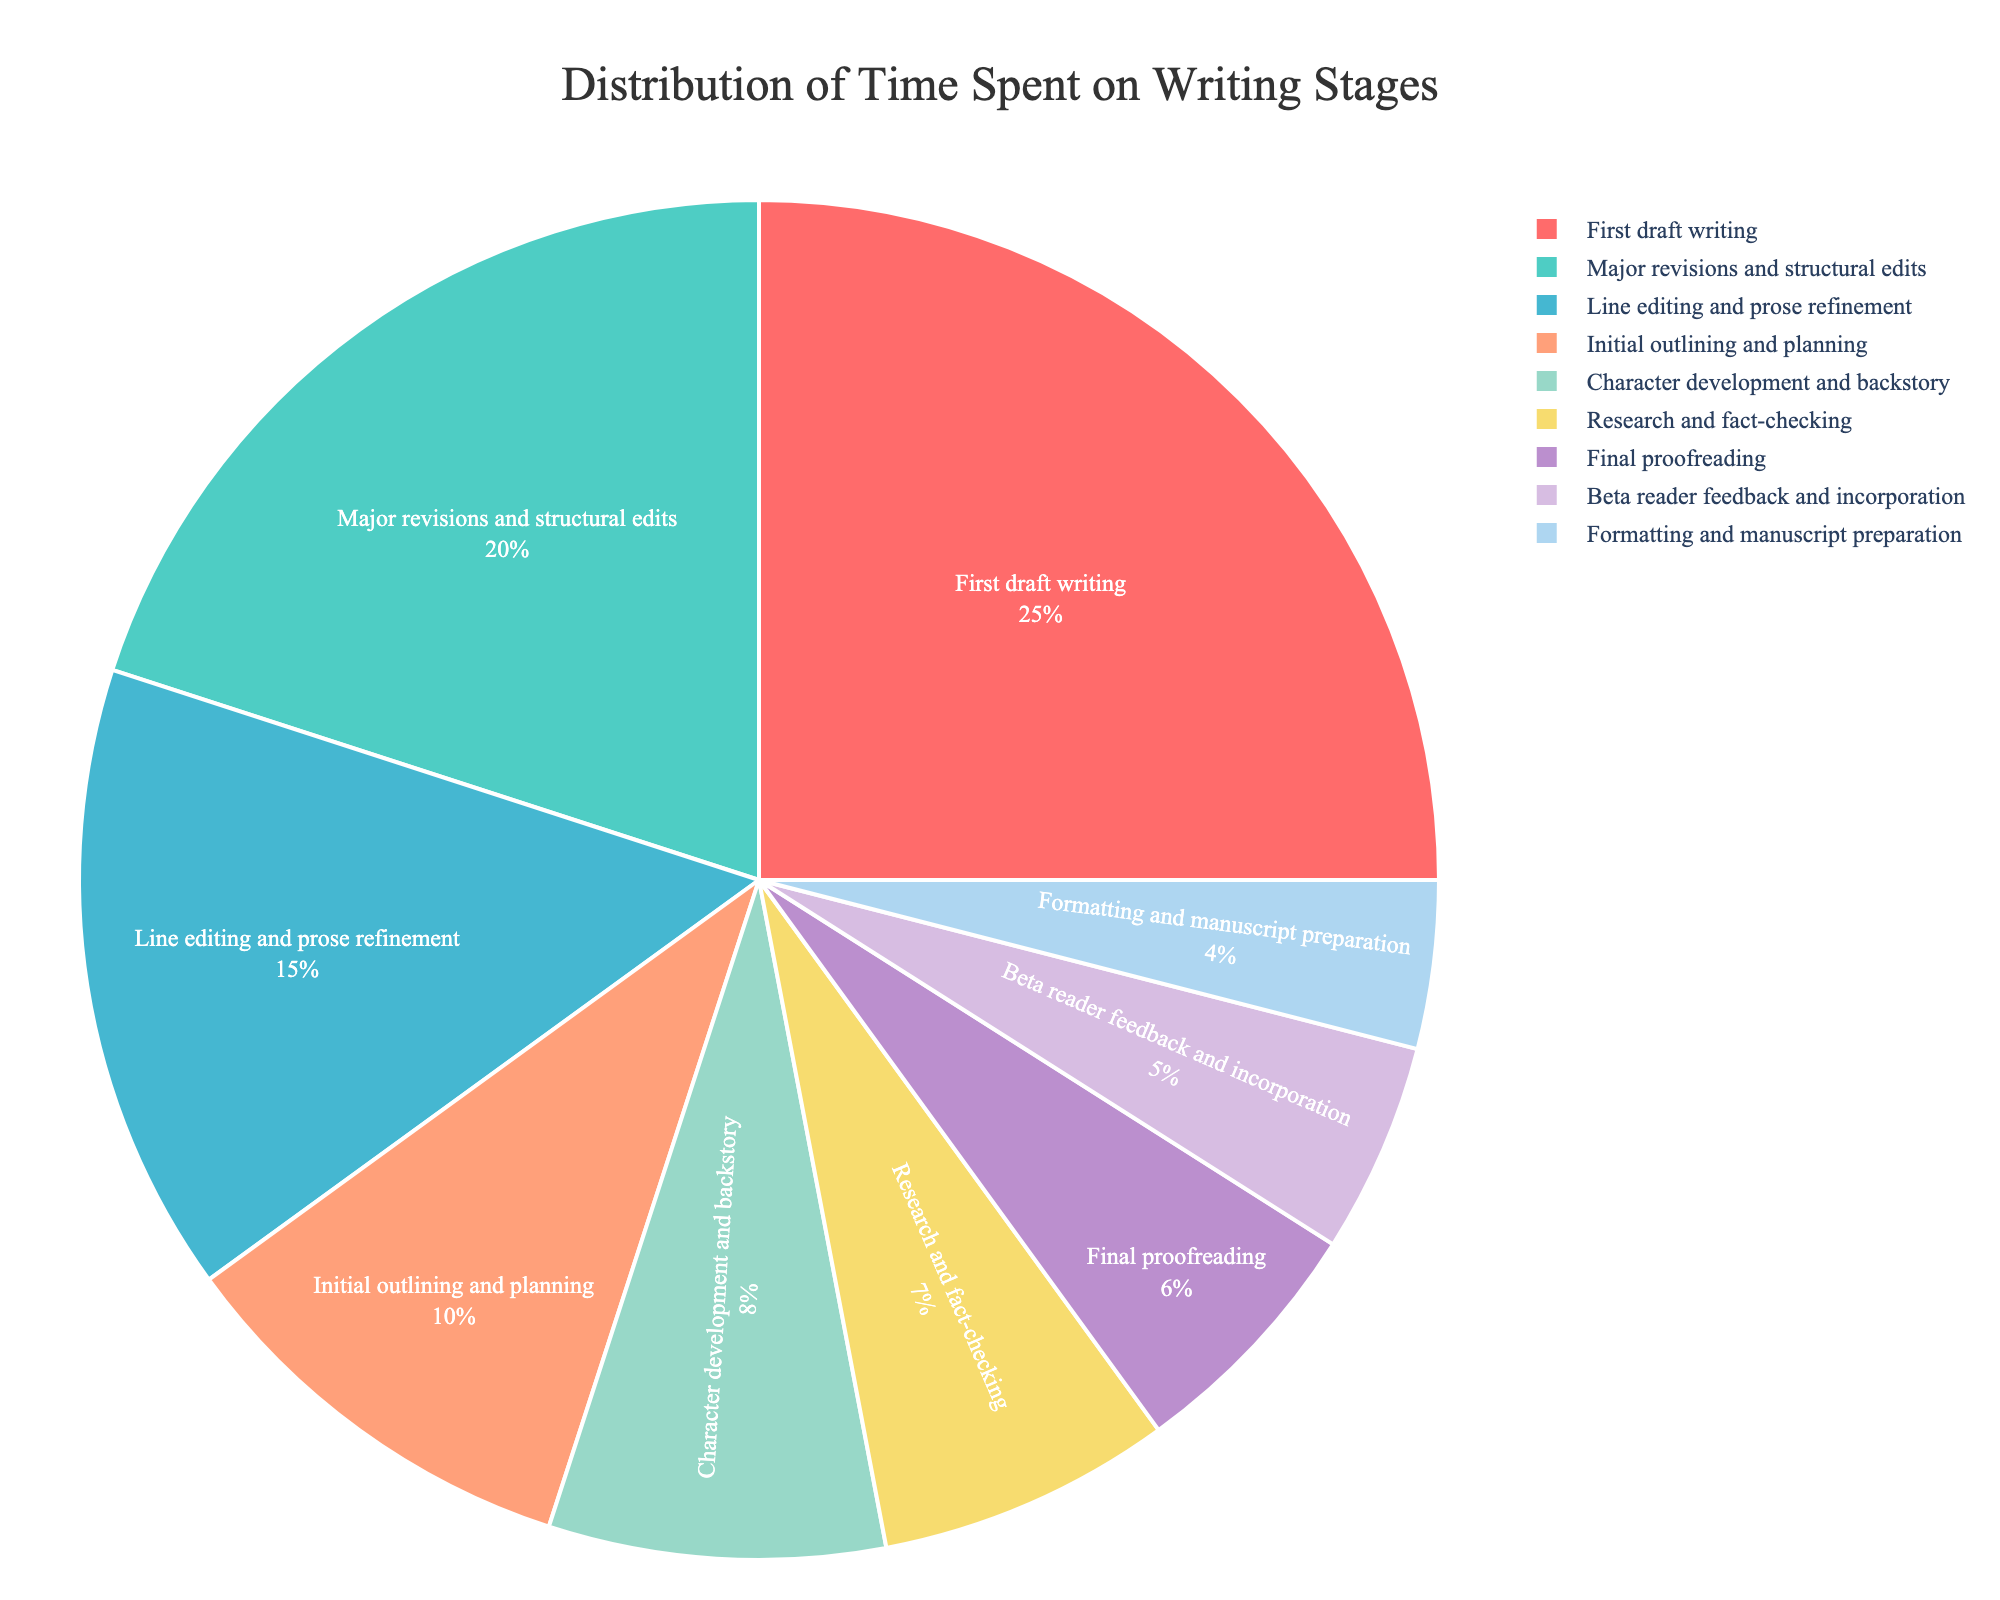Which stage takes the highest percentage of time? The figure shows the "First draft writing" stage taking up 25% of the time, which is the largest slice in the pie chart.
Answer: First draft writing How much more time is spent on major revisions and structural edits compared to final proofreading? The pie chart shows that "Major revisions and structural edits" take 20% of the time, whereas "Final proofreading" takes 6%. The difference is 20% - 6% = 14%.
Answer: 14% What is the combined percentage of time spent on research and fact-checking, and beta reader feedback and incorporation? According to the pie chart, "Research and fact-checking" takes 7%, and "Beta reader feedback and incorporation" takes 5%. Adding these values gives 7% + 5% = 12%.
Answer: 12% Which stage uses more time: Character development and backstory or formatting and manuscript preparation? The pie chart shows that "Character development and backstory" takes 8%, while "Formatting and manuscript preparation" takes 4%. Thus, character development and backstory uses more time.
Answer: Character development and backstory Is more time spent on line editing and prose refinement or on initial outlining and planning? The pie chart indicates that "Line editing and prose refinement" takes 15% of the time, while "Initial outlining and planning" takes 10%. Thus, more time is spent on line editing and prose refinement.
Answer: Line editing and prose refinement What is the total percentage of time spent from major revisions to final proofreading? The stages involved are "Major revisions and structural edits" (20%), "Line editing and prose refinement" (15%), "Beta reader feedback and incorporation" (5%), and "Final proofreading" (6%). Summing these gives 20% + 15% + 5% + 6% = 46%.
Answer: 46% Which stages occupy the smallest slices in the pie chart? The pie chart shows that "Formatting and manuscript preparation" at 4%, and "Beta reader feedback and incorporation" at 5%, are the smallest slices.
Answer: Formatting and manuscript preparation, Beta reader feedback and incorporation How does time spent on character development and backstory compare to time spent on research and fact-checking? The chart shows "Character development and backstory" taking 8%, and "Research and fact-checking" taking 7%. Character development and backstory takes 1% more time.
Answer: Character development and backstory takes 1% more time If the time spent on major revisions and structural edits and line editing and prose refinement were combined, what percentage of the whole process would they cover? Combined, "Major revisions and structural edits" (20%) and "Line editing and prose refinement" (15%) would total 20% + 15% = 35%.
Answer: 35% What is the average percentage of time spent on all stages? The total percentage for all stages combined is 100%. With 9 stages, the average percentage is calculated as 100% / 9 = 11.11%.
Answer: 11.11% 